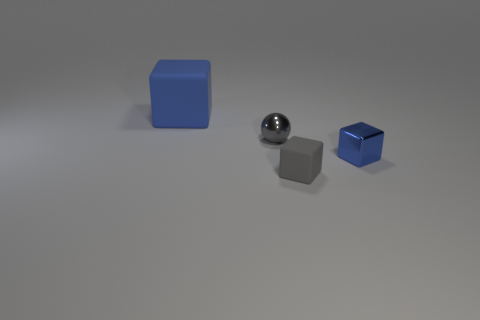Subtract all tiny cubes. How many cubes are left? 1 Subtract all gray cubes. How many cubes are left? 2 Subtract all blocks. How many objects are left? 1 Subtract all green balls. Subtract all red blocks. How many balls are left? 1 Add 3 cubes. How many objects exist? 7 Subtract 0 yellow cylinders. How many objects are left? 4 Subtract all brown cylinders. How many blue cubes are left? 2 Subtract all purple metal cylinders. Subtract all small blue metal objects. How many objects are left? 3 Add 1 blue things. How many blue things are left? 3 Add 1 small purple shiny cubes. How many small purple shiny cubes exist? 1 